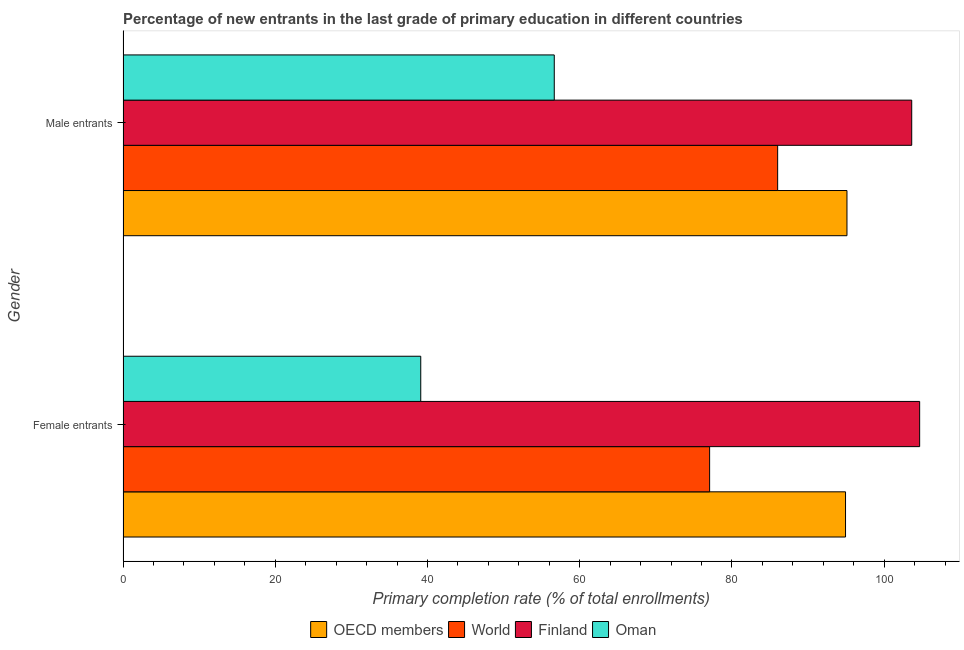Are the number of bars per tick equal to the number of legend labels?
Provide a succinct answer. Yes. Are the number of bars on each tick of the Y-axis equal?
Offer a terse response. Yes. How many bars are there on the 1st tick from the bottom?
Make the answer very short. 4. What is the label of the 1st group of bars from the top?
Provide a short and direct response. Male entrants. What is the primary completion rate of male entrants in Oman?
Your answer should be compact. 56.66. Across all countries, what is the maximum primary completion rate of female entrants?
Provide a succinct answer. 104.66. Across all countries, what is the minimum primary completion rate of male entrants?
Ensure brevity in your answer.  56.66. In which country was the primary completion rate of female entrants minimum?
Make the answer very short. Oman. What is the total primary completion rate of female entrants in the graph?
Ensure brevity in your answer.  315.78. What is the difference between the primary completion rate of male entrants in Oman and that in Finland?
Provide a short and direct response. -46.96. What is the difference between the primary completion rate of female entrants in Oman and the primary completion rate of male entrants in OECD members?
Offer a very short reply. -55.99. What is the average primary completion rate of female entrants per country?
Make the answer very short. 78.94. What is the difference between the primary completion rate of male entrants and primary completion rate of female entrants in Oman?
Offer a terse response. 17.54. In how many countries, is the primary completion rate of male entrants greater than 92 %?
Offer a very short reply. 2. What is the ratio of the primary completion rate of female entrants in Finland to that in World?
Give a very brief answer. 1.36. Is the primary completion rate of female entrants in OECD members less than that in Finland?
Provide a short and direct response. Yes. In how many countries, is the primary completion rate of female entrants greater than the average primary completion rate of female entrants taken over all countries?
Your answer should be very brief. 2. What does the 1st bar from the bottom in Male entrants represents?
Make the answer very short. OECD members. Are all the bars in the graph horizontal?
Your answer should be compact. Yes. How many countries are there in the graph?
Make the answer very short. 4. What is the difference between two consecutive major ticks on the X-axis?
Ensure brevity in your answer.  20. Does the graph contain any zero values?
Offer a terse response. No. Does the graph contain grids?
Offer a terse response. No. What is the title of the graph?
Provide a succinct answer. Percentage of new entrants in the last grade of primary education in different countries. Does "Colombia" appear as one of the legend labels in the graph?
Provide a succinct answer. No. What is the label or title of the X-axis?
Your answer should be very brief. Primary completion rate (% of total enrollments). What is the label or title of the Y-axis?
Provide a succinct answer. Gender. What is the Primary completion rate (% of total enrollments) of OECD members in Female entrants?
Offer a very short reply. 94.93. What is the Primary completion rate (% of total enrollments) of World in Female entrants?
Your answer should be very brief. 77.07. What is the Primary completion rate (% of total enrollments) of Finland in Female entrants?
Give a very brief answer. 104.66. What is the Primary completion rate (% of total enrollments) in Oman in Female entrants?
Your answer should be compact. 39.12. What is the Primary completion rate (% of total enrollments) of OECD members in Male entrants?
Your response must be concise. 95.11. What is the Primary completion rate (% of total enrollments) of World in Male entrants?
Your answer should be compact. 86.01. What is the Primary completion rate (% of total enrollments) in Finland in Male entrants?
Provide a short and direct response. 103.62. What is the Primary completion rate (% of total enrollments) of Oman in Male entrants?
Offer a terse response. 56.66. Across all Gender, what is the maximum Primary completion rate (% of total enrollments) of OECD members?
Offer a very short reply. 95.11. Across all Gender, what is the maximum Primary completion rate (% of total enrollments) in World?
Make the answer very short. 86.01. Across all Gender, what is the maximum Primary completion rate (% of total enrollments) in Finland?
Your response must be concise. 104.66. Across all Gender, what is the maximum Primary completion rate (% of total enrollments) in Oman?
Make the answer very short. 56.66. Across all Gender, what is the minimum Primary completion rate (% of total enrollments) of OECD members?
Give a very brief answer. 94.93. Across all Gender, what is the minimum Primary completion rate (% of total enrollments) of World?
Provide a succinct answer. 77.07. Across all Gender, what is the minimum Primary completion rate (% of total enrollments) of Finland?
Offer a terse response. 103.62. Across all Gender, what is the minimum Primary completion rate (% of total enrollments) in Oman?
Provide a short and direct response. 39.12. What is the total Primary completion rate (% of total enrollments) of OECD members in the graph?
Your answer should be compact. 190.04. What is the total Primary completion rate (% of total enrollments) of World in the graph?
Make the answer very short. 163.08. What is the total Primary completion rate (% of total enrollments) in Finland in the graph?
Your answer should be very brief. 208.28. What is the total Primary completion rate (% of total enrollments) of Oman in the graph?
Provide a short and direct response. 95.78. What is the difference between the Primary completion rate (% of total enrollments) in OECD members in Female entrants and that in Male entrants?
Your response must be concise. -0.19. What is the difference between the Primary completion rate (% of total enrollments) of World in Female entrants and that in Male entrants?
Provide a succinct answer. -8.94. What is the difference between the Primary completion rate (% of total enrollments) of Finland in Female entrants and that in Male entrants?
Provide a short and direct response. 1.04. What is the difference between the Primary completion rate (% of total enrollments) in Oman in Female entrants and that in Male entrants?
Your answer should be compact. -17.54. What is the difference between the Primary completion rate (% of total enrollments) in OECD members in Female entrants and the Primary completion rate (% of total enrollments) in World in Male entrants?
Give a very brief answer. 8.92. What is the difference between the Primary completion rate (% of total enrollments) in OECD members in Female entrants and the Primary completion rate (% of total enrollments) in Finland in Male entrants?
Offer a very short reply. -8.69. What is the difference between the Primary completion rate (% of total enrollments) of OECD members in Female entrants and the Primary completion rate (% of total enrollments) of Oman in Male entrants?
Keep it short and to the point. 38.27. What is the difference between the Primary completion rate (% of total enrollments) of World in Female entrants and the Primary completion rate (% of total enrollments) of Finland in Male entrants?
Your response must be concise. -26.55. What is the difference between the Primary completion rate (% of total enrollments) of World in Female entrants and the Primary completion rate (% of total enrollments) of Oman in Male entrants?
Provide a succinct answer. 20.41. What is the difference between the Primary completion rate (% of total enrollments) in Finland in Female entrants and the Primary completion rate (% of total enrollments) in Oman in Male entrants?
Make the answer very short. 48.01. What is the average Primary completion rate (% of total enrollments) of OECD members per Gender?
Provide a succinct answer. 95.02. What is the average Primary completion rate (% of total enrollments) of World per Gender?
Keep it short and to the point. 81.54. What is the average Primary completion rate (% of total enrollments) of Finland per Gender?
Make the answer very short. 104.14. What is the average Primary completion rate (% of total enrollments) of Oman per Gender?
Your answer should be very brief. 47.89. What is the difference between the Primary completion rate (% of total enrollments) of OECD members and Primary completion rate (% of total enrollments) of World in Female entrants?
Offer a very short reply. 17.85. What is the difference between the Primary completion rate (% of total enrollments) of OECD members and Primary completion rate (% of total enrollments) of Finland in Female entrants?
Provide a succinct answer. -9.74. What is the difference between the Primary completion rate (% of total enrollments) in OECD members and Primary completion rate (% of total enrollments) in Oman in Female entrants?
Your answer should be very brief. 55.81. What is the difference between the Primary completion rate (% of total enrollments) in World and Primary completion rate (% of total enrollments) in Finland in Female entrants?
Offer a terse response. -27.59. What is the difference between the Primary completion rate (% of total enrollments) in World and Primary completion rate (% of total enrollments) in Oman in Female entrants?
Provide a short and direct response. 37.95. What is the difference between the Primary completion rate (% of total enrollments) in Finland and Primary completion rate (% of total enrollments) in Oman in Female entrants?
Your answer should be compact. 65.54. What is the difference between the Primary completion rate (% of total enrollments) in OECD members and Primary completion rate (% of total enrollments) in World in Male entrants?
Your answer should be compact. 9.11. What is the difference between the Primary completion rate (% of total enrollments) of OECD members and Primary completion rate (% of total enrollments) of Finland in Male entrants?
Your response must be concise. -8.51. What is the difference between the Primary completion rate (% of total enrollments) of OECD members and Primary completion rate (% of total enrollments) of Oman in Male entrants?
Your answer should be compact. 38.45. What is the difference between the Primary completion rate (% of total enrollments) in World and Primary completion rate (% of total enrollments) in Finland in Male entrants?
Keep it short and to the point. -17.61. What is the difference between the Primary completion rate (% of total enrollments) in World and Primary completion rate (% of total enrollments) in Oman in Male entrants?
Give a very brief answer. 29.35. What is the difference between the Primary completion rate (% of total enrollments) in Finland and Primary completion rate (% of total enrollments) in Oman in Male entrants?
Keep it short and to the point. 46.96. What is the ratio of the Primary completion rate (% of total enrollments) in OECD members in Female entrants to that in Male entrants?
Your answer should be very brief. 1. What is the ratio of the Primary completion rate (% of total enrollments) of World in Female entrants to that in Male entrants?
Offer a terse response. 0.9. What is the ratio of the Primary completion rate (% of total enrollments) of Oman in Female entrants to that in Male entrants?
Provide a succinct answer. 0.69. What is the difference between the highest and the second highest Primary completion rate (% of total enrollments) of OECD members?
Provide a short and direct response. 0.19. What is the difference between the highest and the second highest Primary completion rate (% of total enrollments) of World?
Keep it short and to the point. 8.94. What is the difference between the highest and the second highest Primary completion rate (% of total enrollments) of Finland?
Give a very brief answer. 1.04. What is the difference between the highest and the second highest Primary completion rate (% of total enrollments) in Oman?
Your answer should be very brief. 17.54. What is the difference between the highest and the lowest Primary completion rate (% of total enrollments) in OECD members?
Offer a terse response. 0.19. What is the difference between the highest and the lowest Primary completion rate (% of total enrollments) in World?
Keep it short and to the point. 8.94. What is the difference between the highest and the lowest Primary completion rate (% of total enrollments) of Finland?
Make the answer very short. 1.04. What is the difference between the highest and the lowest Primary completion rate (% of total enrollments) of Oman?
Keep it short and to the point. 17.54. 